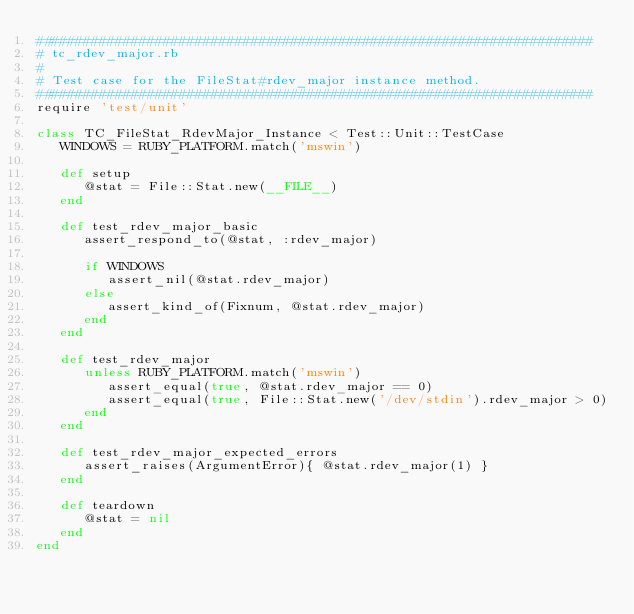<code> <loc_0><loc_0><loc_500><loc_500><_Ruby_>######################################################################
# tc_rdev_major.rb
#
# Test case for the FileStat#rdev_major instance method.
######################################################################
require 'test/unit'

class TC_FileStat_RdevMajor_Instance < Test::Unit::TestCase
   WINDOWS = RUBY_PLATFORM.match('mswin')
   
   def setup
      @stat = File::Stat.new(__FILE__)
   end

   def test_rdev_major_basic
      assert_respond_to(@stat, :rdev_major)
      
      if WINDOWS
         assert_nil(@stat.rdev_major)
      else
         assert_kind_of(Fixnum, @stat.rdev_major)
      end
   end

   def test_rdev_major
      unless RUBY_PLATFORM.match('mswin')
         assert_equal(true, @stat.rdev_major == 0)
         assert_equal(true, File::Stat.new('/dev/stdin').rdev_major > 0)
      end
   end

   def test_rdev_major_expected_errors
      assert_raises(ArgumentError){ @stat.rdev_major(1) }
   end

   def teardown
      @stat = nil
   end
end
</code> 